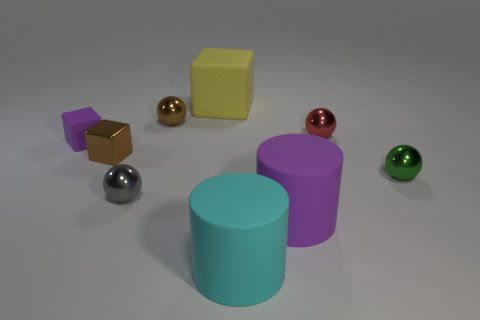How do the objects in the image relate to one another in size? The objects vary in size, creating an interesting composition. The two cylindrical objects are the largest, with the cyan one being the tallest in the scene. The spheres and cubes are much smaller in comparison, with the spheres depicting a range of sizes that seem to decrease in diameter from the gold to the green one. This size variation among the objects could reflect a scaling system or simply a way to create depth and perspective in the image. 